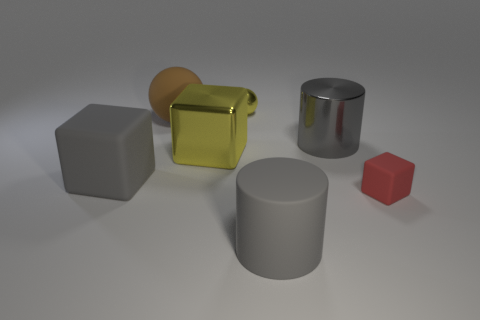Do the gray metallic object and the red rubber cube have the same size?
Make the answer very short. No. There is a large thing that is in front of the big metallic cube and on the right side of the tiny shiny object; what color is it?
Your answer should be compact. Gray. The big thing in front of the cube that is to the left of the brown object is made of what material?
Make the answer very short. Rubber. The gray thing that is the same shape as the large yellow metal object is what size?
Provide a short and direct response. Large. There is a ball that is right of the big yellow metal cube; is it the same color as the big rubber sphere?
Provide a succinct answer. No. Is the number of shiny objects less than the number of small yellow spheres?
Offer a terse response. No. How many other objects are the same color as the tiny shiny sphere?
Provide a short and direct response. 1. Is the gray cylinder in front of the red thing made of the same material as the large yellow block?
Offer a very short reply. No. There is a cylinder in front of the red cube; what is it made of?
Ensure brevity in your answer.  Rubber. How big is the gray cylinder that is behind the big gray matte thing that is on the left side of the large brown thing?
Provide a succinct answer. Large. 